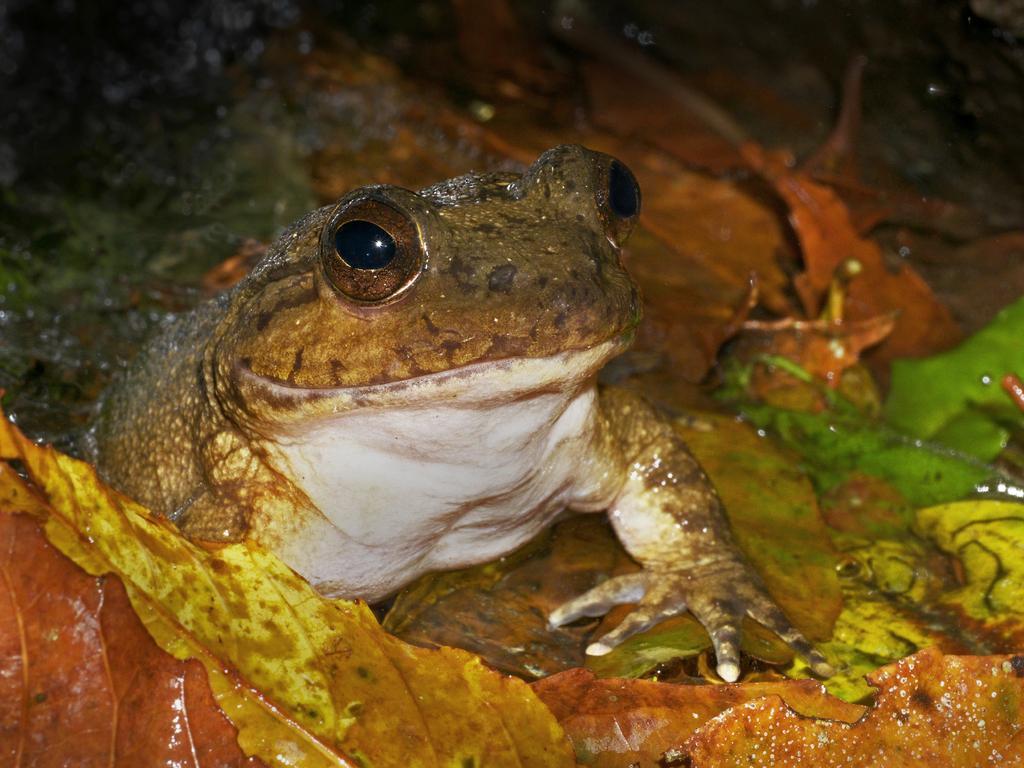Describe this image in one or two sentences. In the center of the image, we can see a frog on the leaves. 